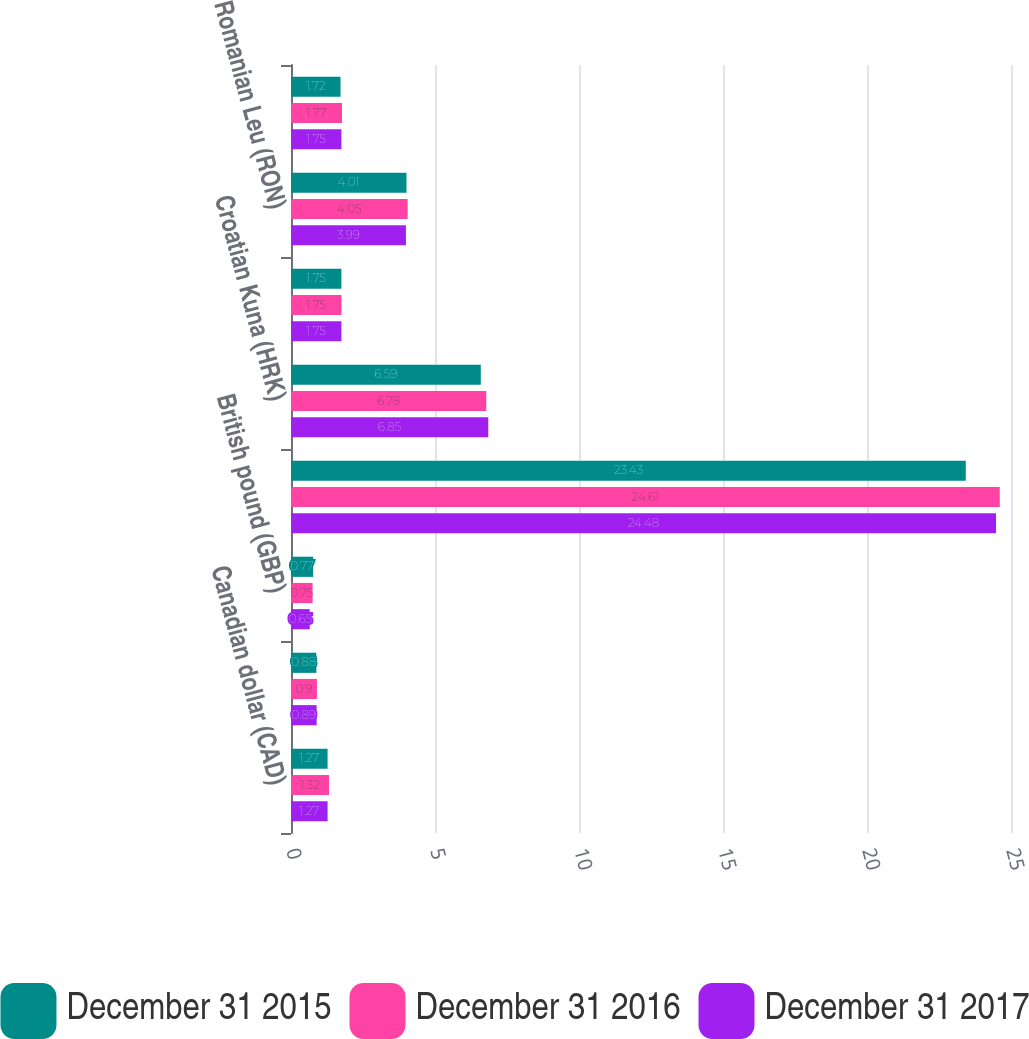Convert chart. <chart><loc_0><loc_0><loc_500><loc_500><stacked_bar_chart><ecel><fcel>Canadian dollar (CAD)<fcel>Euro (EUR)<fcel>British pound (GBP)<fcel>Czech Koruna (CZK)<fcel>Croatian Kuna (HRK)<fcel>Serbian Dinar (RSD)<fcel>Romanian Leu (RON)<fcel>Bulgarian Lev (BGN)<nl><fcel>December 31 2015<fcel>1.27<fcel>0.88<fcel>0.77<fcel>23.43<fcel>6.59<fcel>1.75<fcel>4.01<fcel>1.72<nl><fcel>December 31 2016<fcel>1.32<fcel>0.9<fcel>0.75<fcel>24.61<fcel>6.78<fcel>1.75<fcel>4.05<fcel>1.77<nl><fcel>December 31 2017<fcel>1.27<fcel>0.89<fcel>0.65<fcel>24.48<fcel>6.85<fcel>1.75<fcel>3.99<fcel>1.75<nl></chart> 